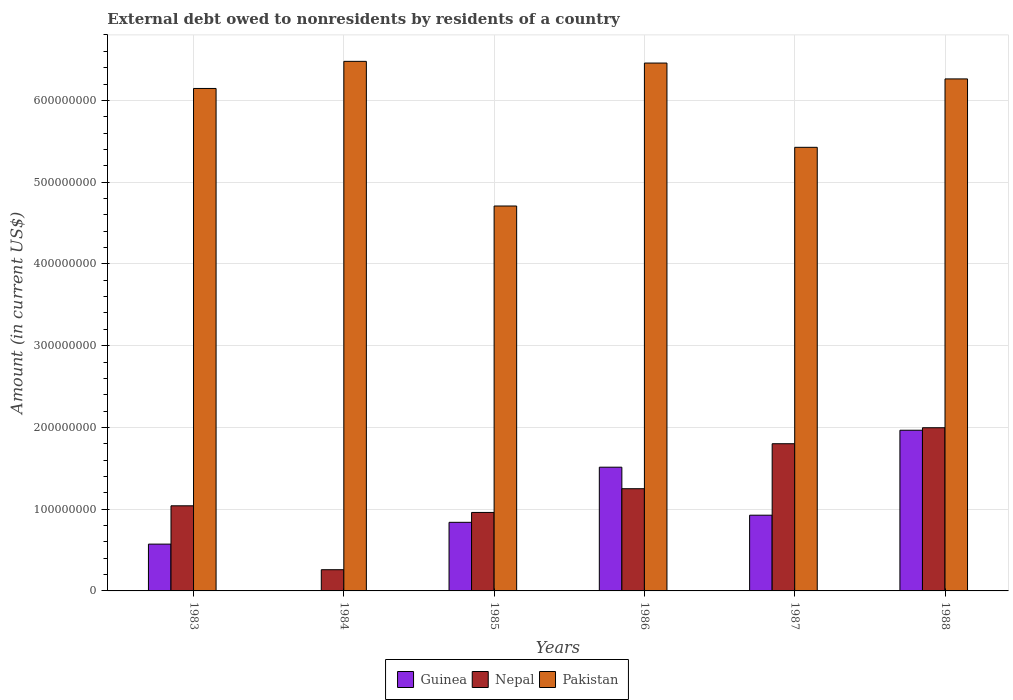How many groups of bars are there?
Offer a very short reply. 6. Are the number of bars on each tick of the X-axis equal?
Your response must be concise. No. How many bars are there on the 5th tick from the left?
Ensure brevity in your answer.  3. What is the external debt owed by residents in Nepal in 1986?
Your response must be concise. 1.25e+08. Across all years, what is the maximum external debt owed by residents in Pakistan?
Your answer should be very brief. 6.48e+08. Across all years, what is the minimum external debt owed by residents in Nepal?
Your response must be concise. 2.59e+07. In which year was the external debt owed by residents in Nepal maximum?
Your answer should be compact. 1988. What is the total external debt owed by residents in Guinea in the graph?
Give a very brief answer. 5.82e+08. What is the difference between the external debt owed by residents in Guinea in 1986 and that in 1988?
Offer a terse response. -4.52e+07. What is the difference between the external debt owed by residents in Nepal in 1987 and the external debt owed by residents in Pakistan in 1984?
Provide a succinct answer. -4.68e+08. What is the average external debt owed by residents in Guinea per year?
Provide a succinct answer. 9.69e+07. In the year 1987, what is the difference between the external debt owed by residents in Nepal and external debt owed by residents in Pakistan?
Your response must be concise. -3.63e+08. What is the ratio of the external debt owed by residents in Pakistan in 1985 to that in 1988?
Your response must be concise. 0.75. Is the external debt owed by residents in Pakistan in 1983 less than that in 1988?
Offer a terse response. Yes. What is the difference between the highest and the second highest external debt owed by residents in Guinea?
Provide a short and direct response. 4.52e+07. What is the difference between the highest and the lowest external debt owed by residents in Pakistan?
Offer a terse response. 1.77e+08. In how many years, is the external debt owed by residents in Nepal greater than the average external debt owed by residents in Nepal taken over all years?
Ensure brevity in your answer.  3. Is the sum of the external debt owed by residents in Nepal in 1983 and 1984 greater than the maximum external debt owed by residents in Pakistan across all years?
Offer a terse response. No. Is it the case that in every year, the sum of the external debt owed by residents in Guinea and external debt owed by residents in Nepal is greater than the external debt owed by residents in Pakistan?
Provide a short and direct response. No. How many bars are there?
Keep it short and to the point. 17. What is the difference between two consecutive major ticks on the Y-axis?
Provide a succinct answer. 1.00e+08. Where does the legend appear in the graph?
Provide a short and direct response. Bottom center. What is the title of the graph?
Provide a succinct answer. External debt owed to nonresidents by residents of a country. What is the Amount (in current US$) of Guinea in 1983?
Your answer should be very brief. 5.72e+07. What is the Amount (in current US$) of Nepal in 1983?
Make the answer very short. 1.04e+08. What is the Amount (in current US$) of Pakistan in 1983?
Your response must be concise. 6.15e+08. What is the Amount (in current US$) in Nepal in 1984?
Ensure brevity in your answer.  2.59e+07. What is the Amount (in current US$) in Pakistan in 1984?
Ensure brevity in your answer.  6.48e+08. What is the Amount (in current US$) of Guinea in 1985?
Make the answer very short. 8.39e+07. What is the Amount (in current US$) in Nepal in 1985?
Make the answer very short. 9.60e+07. What is the Amount (in current US$) of Pakistan in 1985?
Your answer should be compact. 4.71e+08. What is the Amount (in current US$) of Guinea in 1986?
Provide a short and direct response. 1.51e+08. What is the Amount (in current US$) of Nepal in 1986?
Ensure brevity in your answer.  1.25e+08. What is the Amount (in current US$) in Pakistan in 1986?
Provide a succinct answer. 6.46e+08. What is the Amount (in current US$) in Guinea in 1987?
Offer a terse response. 9.26e+07. What is the Amount (in current US$) in Nepal in 1987?
Your answer should be very brief. 1.80e+08. What is the Amount (in current US$) of Pakistan in 1987?
Offer a very short reply. 5.43e+08. What is the Amount (in current US$) in Guinea in 1988?
Ensure brevity in your answer.  1.97e+08. What is the Amount (in current US$) in Nepal in 1988?
Offer a terse response. 2.00e+08. What is the Amount (in current US$) of Pakistan in 1988?
Provide a succinct answer. 6.26e+08. Across all years, what is the maximum Amount (in current US$) of Guinea?
Provide a short and direct response. 1.97e+08. Across all years, what is the maximum Amount (in current US$) of Nepal?
Your response must be concise. 2.00e+08. Across all years, what is the maximum Amount (in current US$) in Pakistan?
Give a very brief answer. 6.48e+08. Across all years, what is the minimum Amount (in current US$) in Nepal?
Keep it short and to the point. 2.59e+07. Across all years, what is the minimum Amount (in current US$) of Pakistan?
Your answer should be very brief. 4.71e+08. What is the total Amount (in current US$) in Guinea in the graph?
Your response must be concise. 5.82e+08. What is the total Amount (in current US$) of Nepal in the graph?
Provide a short and direct response. 7.31e+08. What is the total Amount (in current US$) in Pakistan in the graph?
Offer a terse response. 3.55e+09. What is the difference between the Amount (in current US$) in Nepal in 1983 and that in 1984?
Your answer should be compact. 7.82e+07. What is the difference between the Amount (in current US$) in Pakistan in 1983 and that in 1984?
Your answer should be very brief. -3.32e+07. What is the difference between the Amount (in current US$) of Guinea in 1983 and that in 1985?
Offer a terse response. -2.67e+07. What is the difference between the Amount (in current US$) of Nepal in 1983 and that in 1985?
Your response must be concise. 8.13e+06. What is the difference between the Amount (in current US$) of Pakistan in 1983 and that in 1985?
Ensure brevity in your answer.  1.44e+08. What is the difference between the Amount (in current US$) of Guinea in 1983 and that in 1986?
Provide a succinct answer. -9.41e+07. What is the difference between the Amount (in current US$) of Nepal in 1983 and that in 1986?
Keep it short and to the point. -2.09e+07. What is the difference between the Amount (in current US$) of Pakistan in 1983 and that in 1986?
Offer a terse response. -3.11e+07. What is the difference between the Amount (in current US$) of Guinea in 1983 and that in 1987?
Your response must be concise. -3.54e+07. What is the difference between the Amount (in current US$) of Nepal in 1983 and that in 1987?
Your answer should be very brief. -7.59e+07. What is the difference between the Amount (in current US$) of Pakistan in 1983 and that in 1987?
Offer a very short reply. 7.20e+07. What is the difference between the Amount (in current US$) of Guinea in 1983 and that in 1988?
Provide a short and direct response. -1.39e+08. What is the difference between the Amount (in current US$) in Nepal in 1983 and that in 1988?
Offer a very short reply. -9.55e+07. What is the difference between the Amount (in current US$) in Pakistan in 1983 and that in 1988?
Ensure brevity in your answer.  -1.17e+07. What is the difference between the Amount (in current US$) in Nepal in 1984 and that in 1985?
Keep it short and to the point. -7.00e+07. What is the difference between the Amount (in current US$) of Pakistan in 1984 and that in 1985?
Make the answer very short. 1.77e+08. What is the difference between the Amount (in current US$) in Nepal in 1984 and that in 1986?
Your answer should be very brief. -9.91e+07. What is the difference between the Amount (in current US$) of Pakistan in 1984 and that in 1986?
Keep it short and to the point. 2.09e+06. What is the difference between the Amount (in current US$) of Nepal in 1984 and that in 1987?
Your answer should be compact. -1.54e+08. What is the difference between the Amount (in current US$) in Pakistan in 1984 and that in 1987?
Your answer should be very brief. 1.05e+08. What is the difference between the Amount (in current US$) in Nepal in 1984 and that in 1988?
Offer a very short reply. -1.74e+08. What is the difference between the Amount (in current US$) of Pakistan in 1984 and that in 1988?
Provide a succinct answer. 2.15e+07. What is the difference between the Amount (in current US$) in Guinea in 1985 and that in 1986?
Your answer should be compact. -6.74e+07. What is the difference between the Amount (in current US$) in Nepal in 1985 and that in 1986?
Your answer should be compact. -2.90e+07. What is the difference between the Amount (in current US$) of Pakistan in 1985 and that in 1986?
Keep it short and to the point. -1.75e+08. What is the difference between the Amount (in current US$) in Guinea in 1985 and that in 1987?
Ensure brevity in your answer.  -8.70e+06. What is the difference between the Amount (in current US$) of Nepal in 1985 and that in 1987?
Keep it short and to the point. -8.41e+07. What is the difference between the Amount (in current US$) in Pakistan in 1985 and that in 1987?
Offer a terse response. -7.18e+07. What is the difference between the Amount (in current US$) in Guinea in 1985 and that in 1988?
Offer a terse response. -1.13e+08. What is the difference between the Amount (in current US$) in Nepal in 1985 and that in 1988?
Offer a terse response. -1.04e+08. What is the difference between the Amount (in current US$) in Pakistan in 1985 and that in 1988?
Provide a short and direct response. -1.55e+08. What is the difference between the Amount (in current US$) in Guinea in 1986 and that in 1987?
Offer a terse response. 5.87e+07. What is the difference between the Amount (in current US$) in Nepal in 1986 and that in 1987?
Make the answer very short. -5.50e+07. What is the difference between the Amount (in current US$) of Pakistan in 1986 and that in 1987?
Ensure brevity in your answer.  1.03e+08. What is the difference between the Amount (in current US$) of Guinea in 1986 and that in 1988?
Provide a short and direct response. -4.52e+07. What is the difference between the Amount (in current US$) of Nepal in 1986 and that in 1988?
Make the answer very short. -7.46e+07. What is the difference between the Amount (in current US$) of Pakistan in 1986 and that in 1988?
Provide a succinct answer. 1.94e+07. What is the difference between the Amount (in current US$) of Guinea in 1987 and that in 1988?
Offer a very short reply. -1.04e+08. What is the difference between the Amount (in current US$) of Nepal in 1987 and that in 1988?
Your answer should be compact. -1.95e+07. What is the difference between the Amount (in current US$) of Pakistan in 1987 and that in 1988?
Your response must be concise. -8.37e+07. What is the difference between the Amount (in current US$) of Guinea in 1983 and the Amount (in current US$) of Nepal in 1984?
Give a very brief answer. 3.13e+07. What is the difference between the Amount (in current US$) in Guinea in 1983 and the Amount (in current US$) in Pakistan in 1984?
Make the answer very short. -5.91e+08. What is the difference between the Amount (in current US$) of Nepal in 1983 and the Amount (in current US$) of Pakistan in 1984?
Provide a succinct answer. -5.44e+08. What is the difference between the Amount (in current US$) in Guinea in 1983 and the Amount (in current US$) in Nepal in 1985?
Your answer should be compact. -3.88e+07. What is the difference between the Amount (in current US$) of Guinea in 1983 and the Amount (in current US$) of Pakistan in 1985?
Offer a terse response. -4.14e+08. What is the difference between the Amount (in current US$) of Nepal in 1983 and the Amount (in current US$) of Pakistan in 1985?
Your answer should be very brief. -3.67e+08. What is the difference between the Amount (in current US$) of Guinea in 1983 and the Amount (in current US$) of Nepal in 1986?
Make the answer very short. -6.78e+07. What is the difference between the Amount (in current US$) in Guinea in 1983 and the Amount (in current US$) in Pakistan in 1986?
Make the answer very short. -5.88e+08. What is the difference between the Amount (in current US$) of Nepal in 1983 and the Amount (in current US$) of Pakistan in 1986?
Your response must be concise. -5.42e+08. What is the difference between the Amount (in current US$) in Guinea in 1983 and the Amount (in current US$) in Nepal in 1987?
Ensure brevity in your answer.  -1.23e+08. What is the difference between the Amount (in current US$) of Guinea in 1983 and the Amount (in current US$) of Pakistan in 1987?
Ensure brevity in your answer.  -4.85e+08. What is the difference between the Amount (in current US$) of Nepal in 1983 and the Amount (in current US$) of Pakistan in 1987?
Offer a very short reply. -4.38e+08. What is the difference between the Amount (in current US$) of Guinea in 1983 and the Amount (in current US$) of Nepal in 1988?
Offer a very short reply. -1.42e+08. What is the difference between the Amount (in current US$) in Guinea in 1983 and the Amount (in current US$) in Pakistan in 1988?
Your answer should be compact. -5.69e+08. What is the difference between the Amount (in current US$) in Nepal in 1983 and the Amount (in current US$) in Pakistan in 1988?
Give a very brief answer. -5.22e+08. What is the difference between the Amount (in current US$) of Nepal in 1984 and the Amount (in current US$) of Pakistan in 1985?
Give a very brief answer. -4.45e+08. What is the difference between the Amount (in current US$) in Nepal in 1984 and the Amount (in current US$) in Pakistan in 1986?
Keep it short and to the point. -6.20e+08. What is the difference between the Amount (in current US$) of Nepal in 1984 and the Amount (in current US$) of Pakistan in 1987?
Give a very brief answer. -5.17e+08. What is the difference between the Amount (in current US$) in Nepal in 1984 and the Amount (in current US$) in Pakistan in 1988?
Ensure brevity in your answer.  -6.00e+08. What is the difference between the Amount (in current US$) of Guinea in 1985 and the Amount (in current US$) of Nepal in 1986?
Ensure brevity in your answer.  -4.11e+07. What is the difference between the Amount (in current US$) in Guinea in 1985 and the Amount (in current US$) in Pakistan in 1986?
Offer a very short reply. -5.62e+08. What is the difference between the Amount (in current US$) in Nepal in 1985 and the Amount (in current US$) in Pakistan in 1986?
Your response must be concise. -5.50e+08. What is the difference between the Amount (in current US$) in Guinea in 1985 and the Amount (in current US$) in Nepal in 1987?
Ensure brevity in your answer.  -9.61e+07. What is the difference between the Amount (in current US$) of Guinea in 1985 and the Amount (in current US$) of Pakistan in 1987?
Ensure brevity in your answer.  -4.59e+08. What is the difference between the Amount (in current US$) of Nepal in 1985 and the Amount (in current US$) of Pakistan in 1987?
Ensure brevity in your answer.  -4.47e+08. What is the difference between the Amount (in current US$) of Guinea in 1985 and the Amount (in current US$) of Nepal in 1988?
Your answer should be very brief. -1.16e+08. What is the difference between the Amount (in current US$) in Guinea in 1985 and the Amount (in current US$) in Pakistan in 1988?
Give a very brief answer. -5.42e+08. What is the difference between the Amount (in current US$) of Nepal in 1985 and the Amount (in current US$) of Pakistan in 1988?
Provide a succinct answer. -5.30e+08. What is the difference between the Amount (in current US$) in Guinea in 1986 and the Amount (in current US$) in Nepal in 1987?
Keep it short and to the point. -2.87e+07. What is the difference between the Amount (in current US$) of Guinea in 1986 and the Amount (in current US$) of Pakistan in 1987?
Your answer should be very brief. -3.91e+08. What is the difference between the Amount (in current US$) in Nepal in 1986 and the Amount (in current US$) in Pakistan in 1987?
Your answer should be compact. -4.18e+08. What is the difference between the Amount (in current US$) of Guinea in 1986 and the Amount (in current US$) of Nepal in 1988?
Keep it short and to the point. -4.83e+07. What is the difference between the Amount (in current US$) in Guinea in 1986 and the Amount (in current US$) in Pakistan in 1988?
Provide a succinct answer. -4.75e+08. What is the difference between the Amount (in current US$) in Nepal in 1986 and the Amount (in current US$) in Pakistan in 1988?
Keep it short and to the point. -5.01e+08. What is the difference between the Amount (in current US$) in Guinea in 1987 and the Amount (in current US$) in Nepal in 1988?
Your answer should be compact. -1.07e+08. What is the difference between the Amount (in current US$) of Guinea in 1987 and the Amount (in current US$) of Pakistan in 1988?
Your response must be concise. -5.34e+08. What is the difference between the Amount (in current US$) in Nepal in 1987 and the Amount (in current US$) in Pakistan in 1988?
Offer a very short reply. -4.46e+08. What is the average Amount (in current US$) of Guinea per year?
Make the answer very short. 9.69e+07. What is the average Amount (in current US$) in Nepal per year?
Keep it short and to the point. 1.22e+08. What is the average Amount (in current US$) in Pakistan per year?
Your response must be concise. 5.91e+08. In the year 1983, what is the difference between the Amount (in current US$) of Guinea and Amount (in current US$) of Nepal?
Keep it short and to the point. -4.69e+07. In the year 1983, what is the difference between the Amount (in current US$) of Guinea and Amount (in current US$) of Pakistan?
Offer a terse response. -5.57e+08. In the year 1983, what is the difference between the Amount (in current US$) of Nepal and Amount (in current US$) of Pakistan?
Keep it short and to the point. -5.10e+08. In the year 1984, what is the difference between the Amount (in current US$) in Nepal and Amount (in current US$) in Pakistan?
Your answer should be very brief. -6.22e+08. In the year 1985, what is the difference between the Amount (in current US$) of Guinea and Amount (in current US$) of Nepal?
Keep it short and to the point. -1.21e+07. In the year 1985, what is the difference between the Amount (in current US$) in Guinea and Amount (in current US$) in Pakistan?
Keep it short and to the point. -3.87e+08. In the year 1985, what is the difference between the Amount (in current US$) of Nepal and Amount (in current US$) of Pakistan?
Give a very brief answer. -3.75e+08. In the year 1986, what is the difference between the Amount (in current US$) in Guinea and Amount (in current US$) in Nepal?
Your answer should be compact. 2.63e+07. In the year 1986, what is the difference between the Amount (in current US$) of Guinea and Amount (in current US$) of Pakistan?
Provide a succinct answer. -4.94e+08. In the year 1986, what is the difference between the Amount (in current US$) in Nepal and Amount (in current US$) in Pakistan?
Keep it short and to the point. -5.21e+08. In the year 1987, what is the difference between the Amount (in current US$) in Guinea and Amount (in current US$) in Nepal?
Provide a short and direct response. -8.74e+07. In the year 1987, what is the difference between the Amount (in current US$) of Guinea and Amount (in current US$) of Pakistan?
Your answer should be very brief. -4.50e+08. In the year 1987, what is the difference between the Amount (in current US$) of Nepal and Amount (in current US$) of Pakistan?
Provide a short and direct response. -3.63e+08. In the year 1988, what is the difference between the Amount (in current US$) in Guinea and Amount (in current US$) in Nepal?
Your answer should be compact. -3.06e+06. In the year 1988, what is the difference between the Amount (in current US$) of Guinea and Amount (in current US$) of Pakistan?
Ensure brevity in your answer.  -4.30e+08. In the year 1988, what is the difference between the Amount (in current US$) of Nepal and Amount (in current US$) of Pakistan?
Offer a very short reply. -4.27e+08. What is the ratio of the Amount (in current US$) of Nepal in 1983 to that in 1984?
Ensure brevity in your answer.  4.01. What is the ratio of the Amount (in current US$) of Pakistan in 1983 to that in 1984?
Your answer should be very brief. 0.95. What is the ratio of the Amount (in current US$) of Guinea in 1983 to that in 1985?
Offer a terse response. 0.68. What is the ratio of the Amount (in current US$) of Nepal in 1983 to that in 1985?
Offer a terse response. 1.08. What is the ratio of the Amount (in current US$) in Pakistan in 1983 to that in 1985?
Provide a succinct answer. 1.31. What is the ratio of the Amount (in current US$) in Guinea in 1983 to that in 1986?
Provide a short and direct response. 0.38. What is the ratio of the Amount (in current US$) in Nepal in 1983 to that in 1986?
Offer a terse response. 0.83. What is the ratio of the Amount (in current US$) of Pakistan in 1983 to that in 1986?
Make the answer very short. 0.95. What is the ratio of the Amount (in current US$) in Guinea in 1983 to that in 1987?
Give a very brief answer. 0.62. What is the ratio of the Amount (in current US$) in Nepal in 1983 to that in 1987?
Your response must be concise. 0.58. What is the ratio of the Amount (in current US$) of Pakistan in 1983 to that in 1987?
Your answer should be compact. 1.13. What is the ratio of the Amount (in current US$) in Guinea in 1983 to that in 1988?
Offer a very short reply. 0.29. What is the ratio of the Amount (in current US$) of Nepal in 1983 to that in 1988?
Make the answer very short. 0.52. What is the ratio of the Amount (in current US$) in Pakistan in 1983 to that in 1988?
Keep it short and to the point. 0.98. What is the ratio of the Amount (in current US$) of Nepal in 1984 to that in 1985?
Provide a short and direct response. 0.27. What is the ratio of the Amount (in current US$) of Pakistan in 1984 to that in 1985?
Give a very brief answer. 1.38. What is the ratio of the Amount (in current US$) of Nepal in 1984 to that in 1986?
Offer a very short reply. 0.21. What is the ratio of the Amount (in current US$) in Nepal in 1984 to that in 1987?
Provide a short and direct response. 0.14. What is the ratio of the Amount (in current US$) in Pakistan in 1984 to that in 1987?
Offer a very short reply. 1.19. What is the ratio of the Amount (in current US$) in Nepal in 1984 to that in 1988?
Keep it short and to the point. 0.13. What is the ratio of the Amount (in current US$) in Pakistan in 1984 to that in 1988?
Make the answer very short. 1.03. What is the ratio of the Amount (in current US$) of Guinea in 1985 to that in 1986?
Keep it short and to the point. 0.55. What is the ratio of the Amount (in current US$) in Nepal in 1985 to that in 1986?
Ensure brevity in your answer.  0.77. What is the ratio of the Amount (in current US$) in Pakistan in 1985 to that in 1986?
Keep it short and to the point. 0.73. What is the ratio of the Amount (in current US$) in Guinea in 1985 to that in 1987?
Your response must be concise. 0.91. What is the ratio of the Amount (in current US$) in Nepal in 1985 to that in 1987?
Make the answer very short. 0.53. What is the ratio of the Amount (in current US$) of Pakistan in 1985 to that in 1987?
Your answer should be compact. 0.87. What is the ratio of the Amount (in current US$) of Guinea in 1985 to that in 1988?
Provide a succinct answer. 0.43. What is the ratio of the Amount (in current US$) in Nepal in 1985 to that in 1988?
Provide a short and direct response. 0.48. What is the ratio of the Amount (in current US$) of Pakistan in 1985 to that in 1988?
Offer a terse response. 0.75. What is the ratio of the Amount (in current US$) of Guinea in 1986 to that in 1987?
Make the answer very short. 1.63. What is the ratio of the Amount (in current US$) in Nepal in 1986 to that in 1987?
Provide a short and direct response. 0.69. What is the ratio of the Amount (in current US$) in Pakistan in 1986 to that in 1987?
Offer a very short reply. 1.19. What is the ratio of the Amount (in current US$) of Guinea in 1986 to that in 1988?
Ensure brevity in your answer.  0.77. What is the ratio of the Amount (in current US$) of Nepal in 1986 to that in 1988?
Make the answer very short. 0.63. What is the ratio of the Amount (in current US$) in Pakistan in 1986 to that in 1988?
Give a very brief answer. 1.03. What is the ratio of the Amount (in current US$) of Guinea in 1987 to that in 1988?
Give a very brief answer. 0.47. What is the ratio of the Amount (in current US$) of Nepal in 1987 to that in 1988?
Your answer should be compact. 0.9. What is the ratio of the Amount (in current US$) of Pakistan in 1987 to that in 1988?
Provide a succinct answer. 0.87. What is the difference between the highest and the second highest Amount (in current US$) in Guinea?
Your answer should be compact. 4.52e+07. What is the difference between the highest and the second highest Amount (in current US$) in Nepal?
Offer a very short reply. 1.95e+07. What is the difference between the highest and the second highest Amount (in current US$) in Pakistan?
Make the answer very short. 2.09e+06. What is the difference between the highest and the lowest Amount (in current US$) of Guinea?
Your response must be concise. 1.97e+08. What is the difference between the highest and the lowest Amount (in current US$) in Nepal?
Make the answer very short. 1.74e+08. What is the difference between the highest and the lowest Amount (in current US$) in Pakistan?
Give a very brief answer. 1.77e+08. 